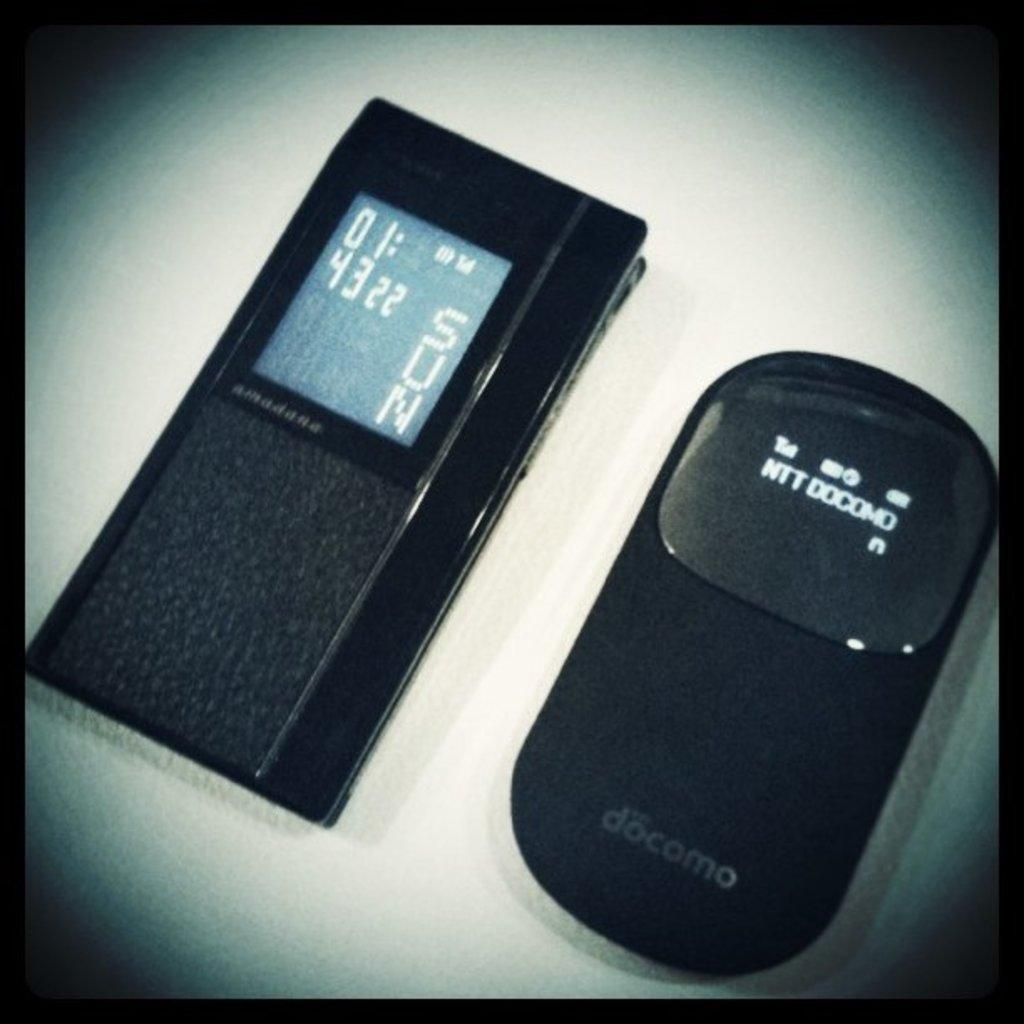<image>
Offer a succinct explanation of the picture presented. A black Docomo device sits next to an Amadana device 